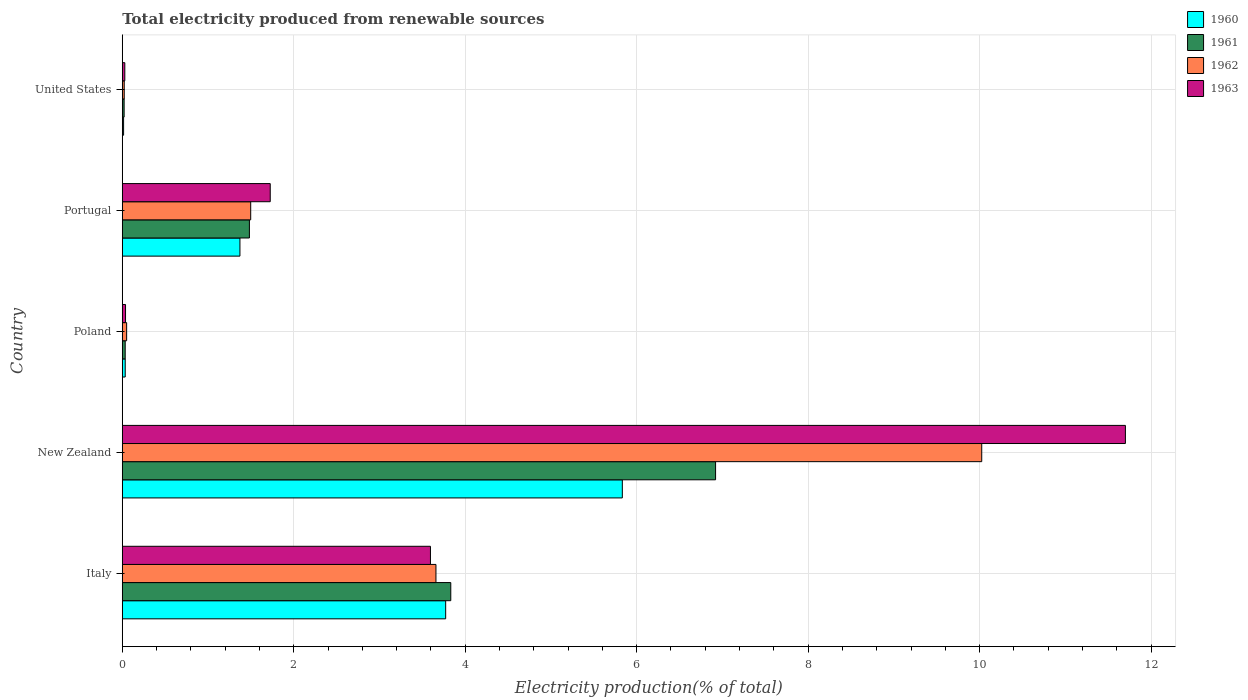How many different coloured bars are there?
Your response must be concise. 4. Are the number of bars on each tick of the Y-axis equal?
Give a very brief answer. Yes. How many bars are there on the 1st tick from the top?
Your response must be concise. 4. How many bars are there on the 1st tick from the bottom?
Make the answer very short. 4. What is the label of the 4th group of bars from the top?
Your answer should be very brief. New Zealand. In how many cases, is the number of bars for a given country not equal to the number of legend labels?
Your response must be concise. 0. What is the total electricity produced in 1962 in New Zealand?
Your answer should be compact. 10.02. Across all countries, what is the maximum total electricity produced in 1962?
Your answer should be very brief. 10.02. Across all countries, what is the minimum total electricity produced in 1962?
Make the answer very short. 0.02. In which country was the total electricity produced in 1960 maximum?
Your answer should be very brief. New Zealand. What is the total total electricity produced in 1963 in the graph?
Ensure brevity in your answer.  17.09. What is the difference between the total electricity produced in 1961 in Portugal and that in United States?
Offer a terse response. 1.46. What is the difference between the total electricity produced in 1963 in Poland and the total electricity produced in 1961 in Portugal?
Offer a terse response. -1.44. What is the average total electricity produced in 1963 per country?
Your answer should be compact. 3.42. What is the difference between the total electricity produced in 1963 and total electricity produced in 1960 in Italy?
Offer a very short reply. -0.18. What is the ratio of the total electricity produced in 1963 in Italy to that in Portugal?
Your answer should be very brief. 2.08. What is the difference between the highest and the second highest total electricity produced in 1962?
Give a very brief answer. 6.37. What is the difference between the highest and the lowest total electricity produced in 1962?
Make the answer very short. 10. Is it the case that in every country, the sum of the total electricity produced in 1961 and total electricity produced in 1963 is greater than the sum of total electricity produced in 1960 and total electricity produced in 1962?
Give a very brief answer. No. What does the 4th bar from the top in United States represents?
Keep it short and to the point. 1960. Is it the case that in every country, the sum of the total electricity produced in 1963 and total electricity produced in 1962 is greater than the total electricity produced in 1960?
Your response must be concise. Yes. How many bars are there?
Provide a short and direct response. 20. Are all the bars in the graph horizontal?
Your answer should be compact. Yes. How many countries are there in the graph?
Your response must be concise. 5. Are the values on the major ticks of X-axis written in scientific E-notation?
Offer a very short reply. No. Does the graph contain any zero values?
Make the answer very short. No. Does the graph contain grids?
Your answer should be compact. Yes. How many legend labels are there?
Make the answer very short. 4. What is the title of the graph?
Give a very brief answer. Total electricity produced from renewable sources. Does "1965" appear as one of the legend labels in the graph?
Your answer should be compact. No. What is the label or title of the X-axis?
Offer a terse response. Electricity production(% of total). What is the Electricity production(% of total) in 1960 in Italy?
Keep it short and to the point. 3.77. What is the Electricity production(% of total) of 1961 in Italy?
Your answer should be compact. 3.83. What is the Electricity production(% of total) of 1962 in Italy?
Your answer should be very brief. 3.66. What is the Electricity production(% of total) of 1963 in Italy?
Your answer should be compact. 3.59. What is the Electricity production(% of total) in 1960 in New Zealand?
Provide a succinct answer. 5.83. What is the Electricity production(% of total) of 1961 in New Zealand?
Offer a terse response. 6.92. What is the Electricity production(% of total) of 1962 in New Zealand?
Give a very brief answer. 10.02. What is the Electricity production(% of total) of 1963 in New Zealand?
Offer a very short reply. 11.7. What is the Electricity production(% of total) of 1960 in Poland?
Provide a succinct answer. 0.03. What is the Electricity production(% of total) of 1961 in Poland?
Your answer should be compact. 0.03. What is the Electricity production(% of total) in 1962 in Poland?
Offer a very short reply. 0.05. What is the Electricity production(% of total) in 1963 in Poland?
Your answer should be compact. 0.04. What is the Electricity production(% of total) in 1960 in Portugal?
Ensure brevity in your answer.  1.37. What is the Electricity production(% of total) of 1961 in Portugal?
Your answer should be compact. 1.48. What is the Electricity production(% of total) of 1962 in Portugal?
Give a very brief answer. 1.5. What is the Electricity production(% of total) in 1963 in Portugal?
Keep it short and to the point. 1.73. What is the Electricity production(% of total) of 1960 in United States?
Offer a very short reply. 0.02. What is the Electricity production(% of total) of 1961 in United States?
Give a very brief answer. 0.02. What is the Electricity production(% of total) of 1962 in United States?
Offer a terse response. 0.02. What is the Electricity production(% of total) in 1963 in United States?
Keep it short and to the point. 0.03. Across all countries, what is the maximum Electricity production(% of total) of 1960?
Give a very brief answer. 5.83. Across all countries, what is the maximum Electricity production(% of total) of 1961?
Ensure brevity in your answer.  6.92. Across all countries, what is the maximum Electricity production(% of total) in 1962?
Provide a short and direct response. 10.02. Across all countries, what is the maximum Electricity production(% of total) in 1963?
Offer a terse response. 11.7. Across all countries, what is the minimum Electricity production(% of total) of 1960?
Offer a very short reply. 0.02. Across all countries, what is the minimum Electricity production(% of total) in 1961?
Keep it short and to the point. 0.02. Across all countries, what is the minimum Electricity production(% of total) in 1962?
Offer a terse response. 0.02. Across all countries, what is the minimum Electricity production(% of total) in 1963?
Your answer should be very brief. 0.03. What is the total Electricity production(% of total) of 1960 in the graph?
Keep it short and to the point. 11.03. What is the total Electricity production(% of total) in 1961 in the graph?
Your response must be concise. 12.29. What is the total Electricity production(% of total) in 1962 in the graph?
Offer a terse response. 15.25. What is the total Electricity production(% of total) in 1963 in the graph?
Give a very brief answer. 17.09. What is the difference between the Electricity production(% of total) of 1960 in Italy and that in New Zealand?
Give a very brief answer. -2.06. What is the difference between the Electricity production(% of total) in 1961 in Italy and that in New Zealand?
Keep it short and to the point. -3.09. What is the difference between the Electricity production(% of total) in 1962 in Italy and that in New Zealand?
Your answer should be compact. -6.37. What is the difference between the Electricity production(% of total) of 1963 in Italy and that in New Zealand?
Provide a short and direct response. -8.11. What is the difference between the Electricity production(% of total) in 1960 in Italy and that in Poland?
Keep it short and to the point. 3.74. What is the difference between the Electricity production(% of total) of 1961 in Italy and that in Poland?
Your response must be concise. 3.8. What is the difference between the Electricity production(% of total) of 1962 in Italy and that in Poland?
Provide a succinct answer. 3.61. What is the difference between the Electricity production(% of total) of 1963 in Italy and that in Poland?
Give a very brief answer. 3.56. What is the difference between the Electricity production(% of total) in 1960 in Italy and that in Portugal?
Ensure brevity in your answer.  2.4. What is the difference between the Electricity production(% of total) of 1961 in Italy and that in Portugal?
Provide a succinct answer. 2.35. What is the difference between the Electricity production(% of total) in 1962 in Italy and that in Portugal?
Give a very brief answer. 2.16. What is the difference between the Electricity production(% of total) in 1963 in Italy and that in Portugal?
Provide a short and direct response. 1.87. What is the difference between the Electricity production(% of total) of 1960 in Italy and that in United States?
Keep it short and to the point. 3.76. What is the difference between the Electricity production(% of total) of 1961 in Italy and that in United States?
Your response must be concise. 3.81. What is the difference between the Electricity production(% of total) of 1962 in Italy and that in United States?
Offer a terse response. 3.64. What is the difference between the Electricity production(% of total) of 1963 in Italy and that in United States?
Offer a terse response. 3.56. What is the difference between the Electricity production(% of total) of 1960 in New Zealand and that in Poland?
Ensure brevity in your answer.  5.8. What is the difference between the Electricity production(% of total) in 1961 in New Zealand and that in Poland?
Offer a terse response. 6.89. What is the difference between the Electricity production(% of total) in 1962 in New Zealand and that in Poland?
Offer a very short reply. 9.97. What is the difference between the Electricity production(% of total) of 1963 in New Zealand and that in Poland?
Your answer should be compact. 11.66. What is the difference between the Electricity production(% of total) in 1960 in New Zealand and that in Portugal?
Your response must be concise. 4.46. What is the difference between the Electricity production(% of total) in 1961 in New Zealand and that in Portugal?
Ensure brevity in your answer.  5.44. What is the difference between the Electricity production(% of total) in 1962 in New Zealand and that in Portugal?
Offer a terse response. 8.53. What is the difference between the Electricity production(% of total) of 1963 in New Zealand and that in Portugal?
Your answer should be very brief. 9.97. What is the difference between the Electricity production(% of total) in 1960 in New Zealand and that in United States?
Ensure brevity in your answer.  5.82. What is the difference between the Electricity production(% of total) in 1961 in New Zealand and that in United States?
Provide a short and direct response. 6.9. What is the difference between the Electricity production(% of total) in 1962 in New Zealand and that in United States?
Give a very brief answer. 10. What is the difference between the Electricity production(% of total) of 1963 in New Zealand and that in United States?
Your answer should be very brief. 11.67. What is the difference between the Electricity production(% of total) of 1960 in Poland and that in Portugal?
Provide a succinct answer. -1.34. What is the difference between the Electricity production(% of total) of 1961 in Poland and that in Portugal?
Your response must be concise. -1.45. What is the difference between the Electricity production(% of total) of 1962 in Poland and that in Portugal?
Offer a very short reply. -1.45. What is the difference between the Electricity production(% of total) in 1963 in Poland and that in Portugal?
Your answer should be compact. -1.69. What is the difference between the Electricity production(% of total) of 1960 in Poland and that in United States?
Ensure brevity in your answer.  0.02. What is the difference between the Electricity production(% of total) of 1961 in Poland and that in United States?
Offer a very short reply. 0.01. What is the difference between the Electricity production(% of total) in 1962 in Poland and that in United States?
Provide a succinct answer. 0.03. What is the difference between the Electricity production(% of total) in 1963 in Poland and that in United States?
Give a very brief answer. 0.01. What is the difference between the Electricity production(% of total) of 1960 in Portugal and that in United States?
Ensure brevity in your answer.  1.36. What is the difference between the Electricity production(% of total) in 1961 in Portugal and that in United States?
Offer a very short reply. 1.46. What is the difference between the Electricity production(% of total) in 1962 in Portugal and that in United States?
Offer a terse response. 1.48. What is the difference between the Electricity production(% of total) of 1963 in Portugal and that in United States?
Give a very brief answer. 1.7. What is the difference between the Electricity production(% of total) of 1960 in Italy and the Electricity production(% of total) of 1961 in New Zealand?
Provide a short and direct response. -3.15. What is the difference between the Electricity production(% of total) of 1960 in Italy and the Electricity production(% of total) of 1962 in New Zealand?
Ensure brevity in your answer.  -6.25. What is the difference between the Electricity production(% of total) in 1960 in Italy and the Electricity production(% of total) in 1963 in New Zealand?
Your answer should be compact. -7.93. What is the difference between the Electricity production(% of total) in 1961 in Italy and the Electricity production(% of total) in 1962 in New Zealand?
Ensure brevity in your answer.  -6.19. What is the difference between the Electricity production(% of total) in 1961 in Italy and the Electricity production(% of total) in 1963 in New Zealand?
Provide a succinct answer. -7.87. What is the difference between the Electricity production(% of total) of 1962 in Italy and the Electricity production(% of total) of 1963 in New Zealand?
Ensure brevity in your answer.  -8.04. What is the difference between the Electricity production(% of total) of 1960 in Italy and the Electricity production(% of total) of 1961 in Poland?
Your answer should be compact. 3.74. What is the difference between the Electricity production(% of total) of 1960 in Italy and the Electricity production(% of total) of 1962 in Poland?
Provide a short and direct response. 3.72. What is the difference between the Electricity production(% of total) in 1960 in Italy and the Electricity production(% of total) in 1963 in Poland?
Offer a very short reply. 3.73. What is the difference between the Electricity production(% of total) of 1961 in Italy and the Electricity production(% of total) of 1962 in Poland?
Your answer should be compact. 3.78. What is the difference between the Electricity production(% of total) of 1961 in Italy and the Electricity production(% of total) of 1963 in Poland?
Provide a short and direct response. 3.79. What is the difference between the Electricity production(% of total) of 1962 in Italy and the Electricity production(% of total) of 1963 in Poland?
Provide a short and direct response. 3.62. What is the difference between the Electricity production(% of total) in 1960 in Italy and the Electricity production(% of total) in 1961 in Portugal?
Offer a terse response. 2.29. What is the difference between the Electricity production(% of total) of 1960 in Italy and the Electricity production(% of total) of 1962 in Portugal?
Your answer should be compact. 2.27. What is the difference between the Electricity production(% of total) in 1960 in Italy and the Electricity production(% of total) in 1963 in Portugal?
Provide a succinct answer. 2.05. What is the difference between the Electricity production(% of total) in 1961 in Italy and the Electricity production(% of total) in 1962 in Portugal?
Ensure brevity in your answer.  2.33. What is the difference between the Electricity production(% of total) of 1961 in Italy and the Electricity production(% of total) of 1963 in Portugal?
Your response must be concise. 2.11. What is the difference between the Electricity production(% of total) of 1962 in Italy and the Electricity production(% of total) of 1963 in Portugal?
Make the answer very short. 1.93. What is the difference between the Electricity production(% of total) of 1960 in Italy and the Electricity production(% of total) of 1961 in United States?
Offer a terse response. 3.75. What is the difference between the Electricity production(% of total) of 1960 in Italy and the Electricity production(% of total) of 1962 in United States?
Your answer should be very brief. 3.75. What is the difference between the Electricity production(% of total) in 1960 in Italy and the Electricity production(% of total) in 1963 in United States?
Provide a short and direct response. 3.74. What is the difference between the Electricity production(% of total) in 1961 in Italy and the Electricity production(% of total) in 1962 in United States?
Your response must be concise. 3.81. What is the difference between the Electricity production(% of total) in 1961 in Italy and the Electricity production(% of total) in 1963 in United States?
Keep it short and to the point. 3.8. What is the difference between the Electricity production(% of total) of 1962 in Italy and the Electricity production(% of total) of 1963 in United States?
Make the answer very short. 3.63. What is the difference between the Electricity production(% of total) in 1960 in New Zealand and the Electricity production(% of total) in 1961 in Poland?
Offer a very short reply. 5.8. What is the difference between the Electricity production(% of total) of 1960 in New Zealand and the Electricity production(% of total) of 1962 in Poland?
Offer a very short reply. 5.78. What is the difference between the Electricity production(% of total) of 1960 in New Zealand and the Electricity production(% of total) of 1963 in Poland?
Provide a short and direct response. 5.79. What is the difference between the Electricity production(% of total) in 1961 in New Zealand and the Electricity production(% of total) in 1962 in Poland?
Keep it short and to the point. 6.87. What is the difference between the Electricity production(% of total) in 1961 in New Zealand and the Electricity production(% of total) in 1963 in Poland?
Offer a very short reply. 6.88. What is the difference between the Electricity production(% of total) in 1962 in New Zealand and the Electricity production(% of total) in 1963 in Poland?
Provide a succinct answer. 9.99. What is the difference between the Electricity production(% of total) in 1960 in New Zealand and the Electricity production(% of total) in 1961 in Portugal?
Provide a short and direct response. 4.35. What is the difference between the Electricity production(% of total) in 1960 in New Zealand and the Electricity production(% of total) in 1962 in Portugal?
Ensure brevity in your answer.  4.33. What is the difference between the Electricity production(% of total) of 1960 in New Zealand and the Electricity production(% of total) of 1963 in Portugal?
Offer a terse response. 4.11. What is the difference between the Electricity production(% of total) in 1961 in New Zealand and the Electricity production(% of total) in 1962 in Portugal?
Make the answer very short. 5.42. What is the difference between the Electricity production(% of total) in 1961 in New Zealand and the Electricity production(% of total) in 1963 in Portugal?
Provide a short and direct response. 5.19. What is the difference between the Electricity production(% of total) in 1962 in New Zealand and the Electricity production(% of total) in 1963 in Portugal?
Keep it short and to the point. 8.3. What is the difference between the Electricity production(% of total) of 1960 in New Zealand and the Electricity production(% of total) of 1961 in United States?
Make the answer very short. 5.81. What is the difference between the Electricity production(% of total) of 1960 in New Zealand and the Electricity production(% of total) of 1962 in United States?
Your response must be concise. 5.81. What is the difference between the Electricity production(% of total) of 1960 in New Zealand and the Electricity production(% of total) of 1963 in United States?
Offer a very short reply. 5.8. What is the difference between the Electricity production(% of total) in 1961 in New Zealand and the Electricity production(% of total) in 1962 in United States?
Provide a succinct answer. 6.9. What is the difference between the Electricity production(% of total) in 1961 in New Zealand and the Electricity production(% of total) in 1963 in United States?
Ensure brevity in your answer.  6.89. What is the difference between the Electricity production(% of total) in 1962 in New Zealand and the Electricity production(% of total) in 1963 in United States?
Offer a terse response. 10. What is the difference between the Electricity production(% of total) in 1960 in Poland and the Electricity production(% of total) in 1961 in Portugal?
Offer a very short reply. -1.45. What is the difference between the Electricity production(% of total) in 1960 in Poland and the Electricity production(% of total) in 1962 in Portugal?
Your response must be concise. -1.46. What is the difference between the Electricity production(% of total) of 1960 in Poland and the Electricity production(% of total) of 1963 in Portugal?
Give a very brief answer. -1.69. What is the difference between the Electricity production(% of total) in 1961 in Poland and the Electricity production(% of total) in 1962 in Portugal?
Provide a short and direct response. -1.46. What is the difference between the Electricity production(% of total) of 1961 in Poland and the Electricity production(% of total) of 1963 in Portugal?
Offer a very short reply. -1.69. What is the difference between the Electricity production(% of total) in 1962 in Poland and the Electricity production(% of total) in 1963 in Portugal?
Provide a succinct answer. -1.67. What is the difference between the Electricity production(% of total) in 1960 in Poland and the Electricity production(% of total) in 1961 in United States?
Your answer should be very brief. 0.01. What is the difference between the Electricity production(% of total) of 1960 in Poland and the Electricity production(% of total) of 1962 in United States?
Your response must be concise. 0.01. What is the difference between the Electricity production(% of total) of 1960 in Poland and the Electricity production(% of total) of 1963 in United States?
Give a very brief answer. 0. What is the difference between the Electricity production(% of total) of 1961 in Poland and the Electricity production(% of total) of 1962 in United States?
Provide a short and direct response. 0.01. What is the difference between the Electricity production(% of total) of 1961 in Poland and the Electricity production(% of total) of 1963 in United States?
Ensure brevity in your answer.  0. What is the difference between the Electricity production(% of total) in 1962 in Poland and the Electricity production(% of total) in 1963 in United States?
Your answer should be compact. 0.02. What is the difference between the Electricity production(% of total) of 1960 in Portugal and the Electricity production(% of total) of 1961 in United States?
Offer a very short reply. 1.35. What is the difference between the Electricity production(% of total) in 1960 in Portugal and the Electricity production(% of total) in 1962 in United States?
Offer a terse response. 1.35. What is the difference between the Electricity production(% of total) of 1960 in Portugal and the Electricity production(% of total) of 1963 in United States?
Provide a short and direct response. 1.34. What is the difference between the Electricity production(% of total) in 1961 in Portugal and the Electricity production(% of total) in 1962 in United States?
Keep it short and to the point. 1.46. What is the difference between the Electricity production(% of total) in 1961 in Portugal and the Electricity production(% of total) in 1963 in United States?
Provide a short and direct response. 1.45. What is the difference between the Electricity production(% of total) in 1962 in Portugal and the Electricity production(% of total) in 1963 in United States?
Keep it short and to the point. 1.47. What is the average Electricity production(% of total) of 1960 per country?
Give a very brief answer. 2.21. What is the average Electricity production(% of total) in 1961 per country?
Offer a very short reply. 2.46. What is the average Electricity production(% of total) of 1962 per country?
Your answer should be compact. 3.05. What is the average Electricity production(% of total) in 1963 per country?
Ensure brevity in your answer.  3.42. What is the difference between the Electricity production(% of total) in 1960 and Electricity production(% of total) in 1961 in Italy?
Give a very brief answer. -0.06. What is the difference between the Electricity production(% of total) in 1960 and Electricity production(% of total) in 1962 in Italy?
Make the answer very short. 0.11. What is the difference between the Electricity production(% of total) in 1960 and Electricity production(% of total) in 1963 in Italy?
Make the answer very short. 0.18. What is the difference between the Electricity production(% of total) of 1961 and Electricity production(% of total) of 1962 in Italy?
Keep it short and to the point. 0.17. What is the difference between the Electricity production(% of total) of 1961 and Electricity production(% of total) of 1963 in Italy?
Your response must be concise. 0.24. What is the difference between the Electricity production(% of total) in 1962 and Electricity production(% of total) in 1963 in Italy?
Keep it short and to the point. 0.06. What is the difference between the Electricity production(% of total) in 1960 and Electricity production(% of total) in 1961 in New Zealand?
Provide a short and direct response. -1.09. What is the difference between the Electricity production(% of total) in 1960 and Electricity production(% of total) in 1962 in New Zealand?
Your response must be concise. -4.19. What is the difference between the Electricity production(% of total) of 1960 and Electricity production(% of total) of 1963 in New Zealand?
Your answer should be very brief. -5.87. What is the difference between the Electricity production(% of total) in 1961 and Electricity production(% of total) in 1962 in New Zealand?
Ensure brevity in your answer.  -3.1. What is the difference between the Electricity production(% of total) of 1961 and Electricity production(% of total) of 1963 in New Zealand?
Ensure brevity in your answer.  -4.78. What is the difference between the Electricity production(% of total) in 1962 and Electricity production(% of total) in 1963 in New Zealand?
Offer a very short reply. -1.68. What is the difference between the Electricity production(% of total) in 1960 and Electricity production(% of total) in 1961 in Poland?
Your answer should be compact. 0. What is the difference between the Electricity production(% of total) in 1960 and Electricity production(% of total) in 1962 in Poland?
Ensure brevity in your answer.  -0.02. What is the difference between the Electricity production(% of total) in 1960 and Electricity production(% of total) in 1963 in Poland?
Offer a very short reply. -0. What is the difference between the Electricity production(% of total) in 1961 and Electricity production(% of total) in 1962 in Poland?
Offer a terse response. -0.02. What is the difference between the Electricity production(% of total) in 1961 and Electricity production(% of total) in 1963 in Poland?
Give a very brief answer. -0. What is the difference between the Electricity production(% of total) in 1962 and Electricity production(% of total) in 1963 in Poland?
Provide a succinct answer. 0.01. What is the difference between the Electricity production(% of total) of 1960 and Electricity production(% of total) of 1961 in Portugal?
Your response must be concise. -0.11. What is the difference between the Electricity production(% of total) in 1960 and Electricity production(% of total) in 1962 in Portugal?
Provide a succinct answer. -0.13. What is the difference between the Electricity production(% of total) in 1960 and Electricity production(% of total) in 1963 in Portugal?
Your response must be concise. -0.35. What is the difference between the Electricity production(% of total) in 1961 and Electricity production(% of total) in 1962 in Portugal?
Your response must be concise. -0.02. What is the difference between the Electricity production(% of total) of 1961 and Electricity production(% of total) of 1963 in Portugal?
Your response must be concise. -0.24. What is the difference between the Electricity production(% of total) of 1962 and Electricity production(% of total) of 1963 in Portugal?
Ensure brevity in your answer.  -0.23. What is the difference between the Electricity production(% of total) of 1960 and Electricity production(% of total) of 1961 in United States?
Provide a succinct answer. -0.01. What is the difference between the Electricity production(% of total) in 1960 and Electricity production(% of total) in 1962 in United States?
Make the answer very short. -0.01. What is the difference between the Electricity production(% of total) of 1960 and Electricity production(% of total) of 1963 in United States?
Your answer should be compact. -0.01. What is the difference between the Electricity production(% of total) of 1961 and Electricity production(% of total) of 1962 in United States?
Offer a terse response. -0. What is the difference between the Electricity production(% of total) in 1961 and Electricity production(% of total) in 1963 in United States?
Offer a terse response. -0.01. What is the difference between the Electricity production(% of total) in 1962 and Electricity production(% of total) in 1963 in United States?
Offer a very short reply. -0.01. What is the ratio of the Electricity production(% of total) in 1960 in Italy to that in New Zealand?
Your answer should be compact. 0.65. What is the ratio of the Electricity production(% of total) of 1961 in Italy to that in New Zealand?
Ensure brevity in your answer.  0.55. What is the ratio of the Electricity production(% of total) of 1962 in Italy to that in New Zealand?
Offer a very short reply. 0.36. What is the ratio of the Electricity production(% of total) in 1963 in Italy to that in New Zealand?
Ensure brevity in your answer.  0.31. What is the ratio of the Electricity production(% of total) in 1960 in Italy to that in Poland?
Make the answer very short. 110.45. What is the ratio of the Electricity production(% of total) in 1961 in Italy to that in Poland?
Give a very brief answer. 112.3. What is the ratio of the Electricity production(% of total) in 1962 in Italy to that in Poland?
Provide a succinct answer. 71.88. What is the ratio of the Electricity production(% of total) in 1963 in Italy to that in Poland?
Make the answer very short. 94.84. What is the ratio of the Electricity production(% of total) of 1960 in Italy to that in Portugal?
Offer a terse response. 2.75. What is the ratio of the Electricity production(% of total) in 1961 in Italy to that in Portugal?
Offer a very short reply. 2.58. What is the ratio of the Electricity production(% of total) in 1962 in Italy to that in Portugal?
Your answer should be compact. 2.44. What is the ratio of the Electricity production(% of total) of 1963 in Italy to that in Portugal?
Ensure brevity in your answer.  2.08. What is the ratio of the Electricity production(% of total) in 1960 in Italy to that in United States?
Ensure brevity in your answer.  247.25. What is the ratio of the Electricity production(% of total) in 1961 in Italy to that in United States?
Give a very brief answer. 177.87. What is the ratio of the Electricity production(% of total) in 1962 in Italy to that in United States?
Ensure brevity in your answer.  160.56. What is the ratio of the Electricity production(% of total) in 1963 in Italy to that in United States?
Your response must be concise. 122.12. What is the ratio of the Electricity production(% of total) in 1960 in New Zealand to that in Poland?
Your answer should be compact. 170.79. What is the ratio of the Electricity production(% of total) of 1961 in New Zealand to that in Poland?
Give a very brief answer. 202.83. What is the ratio of the Electricity production(% of total) of 1962 in New Zealand to that in Poland?
Provide a short and direct response. 196.95. What is the ratio of the Electricity production(% of total) of 1963 in New Zealand to that in Poland?
Your response must be concise. 308.73. What is the ratio of the Electricity production(% of total) in 1960 in New Zealand to that in Portugal?
Give a very brief answer. 4.25. What is the ratio of the Electricity production(% of total) of 1961 in New Zealand to that in Portugal?
Your answer should be compact. 4.67. What is the ratio of the Electricity production(% of total) of 1962 in New Zealand to that in Portugal?
Your response must be concise. 6.69. What is the ratio of the Electricity production(% of total) of 1963 in New Zealand to that in Portugal?
Make the answer very short. 6.78. What is the ratio of the Electricity production(% of total) of 1960 in New Zealand to that in United States?
Keep it short and to the point. 382.31. What is the ratio of the Electricity production(% of total) in 1961 in New Zealand to that in United States?
Your answer should be very brief. 321.25. What is the ratio of the Electricity production(% of total) in 1962 in New Zealand to that in United States?
Your response must be concise. 439.93. What is the ratio of the Electricity production(% of total) in 1963 in New Zealand to that in United States?
Provide a succinct answer. 397.5. What is the ratio of the Electricity production(% of total) in 1960 in Poland to that in Portugal?
Offer a terse response. 0.02. What is the ratio of the Electricity production(% of total) in 1961 in Poland to that in Portugal?
Your answer should be compact. 0.02. What is the ratio of the Electricity production(% of total) of 1962 in Poland to that in Portugal?
Give a very brief answer. 0.03. What is the ratio of the Electricity production(% of total) of 1963 in Poland to that in Portugal?
Give a very brief answer. 0.02. What is the ratio of the Electricity production(% of total) in 1960 in Poland to that in United States?
Your answer should be compact. 2.24. What is the ratio of the Electricity production(% of total) of 1961 in Poland to that in United States?
Make the answer very short. 1.58. What is the ratio of the Electricity production(% of total) of 1962 in Poland to that in United States?
Offer a terse response. 2.23. What is the ratio of the Electricity production(% of total) in 1963 in Poland to that in United States?
Offer a terse response. 1.29. What is the ratio of the Electricity production(% of total) of 1960 in Portugal to that in United States?
Provide a short and direct response. 89.96. What is the ratio of the Electricity production(% of total) of 1961 in Portugal to that in United States?
Make the answer very short. 68.83. What is the ratio of the Electricity production(% of total) of 1962 in Portugal to that in United States?
Provide a short and direct response. 65.74. What is the ratio of the Electricity production(% of total) in 1963 in Portugal to that in United States?
Your response must be concise. 58.63. What is the difference between the highest and the second highest Electricity production(% of total) of 1960?
Provide a short and direct response. 2.06. What is the difference between the highest and the second highest Electricity production(% of total) in 1961?
Provide a short and direct response. 3.09. What is the difference between the highest and the second highest Electricity production(% of total) in 1962?
Keep it short and to the point. 6.37. What is the difference between the highest and the second highest Electricity production(% of total) in 1963?
Offer a very short reply. 8.11. What is the difference between the highest and the lowest Electricity production(% of total) of 1960?
Give a very brief answer. 5.82. What is the difference between the highest and the lowest Electricity production(% of total) of 1961?
Provide a succinct answer. 6.9. What is the difference between the highest and the lowest Electricity production(% of total) in 1962?
Your answer should be compact. 10. What is the difference between the highest and the lowest Electricity production(% of total) of 1963?
Make the answer very short. 11.67. 